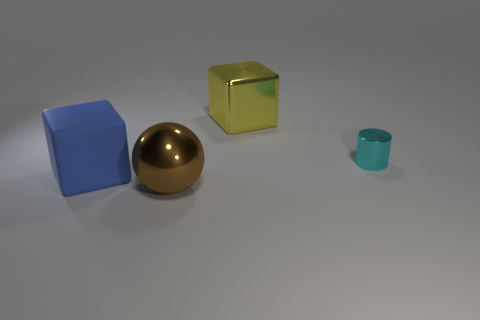What materials are the objects in the image made of? The objects in the image appear to be made of different materials. From left to right: the first object is a cube with a matte surface, possibly representing rubber. The spherical object seems to have a reflective surface, hinting at a metal-like material. The cube in the center has a slight translucence, suggesting a glass or plastic material, whereas the small object on the right looks similar to the first cube, possibly made of rubber as well. 